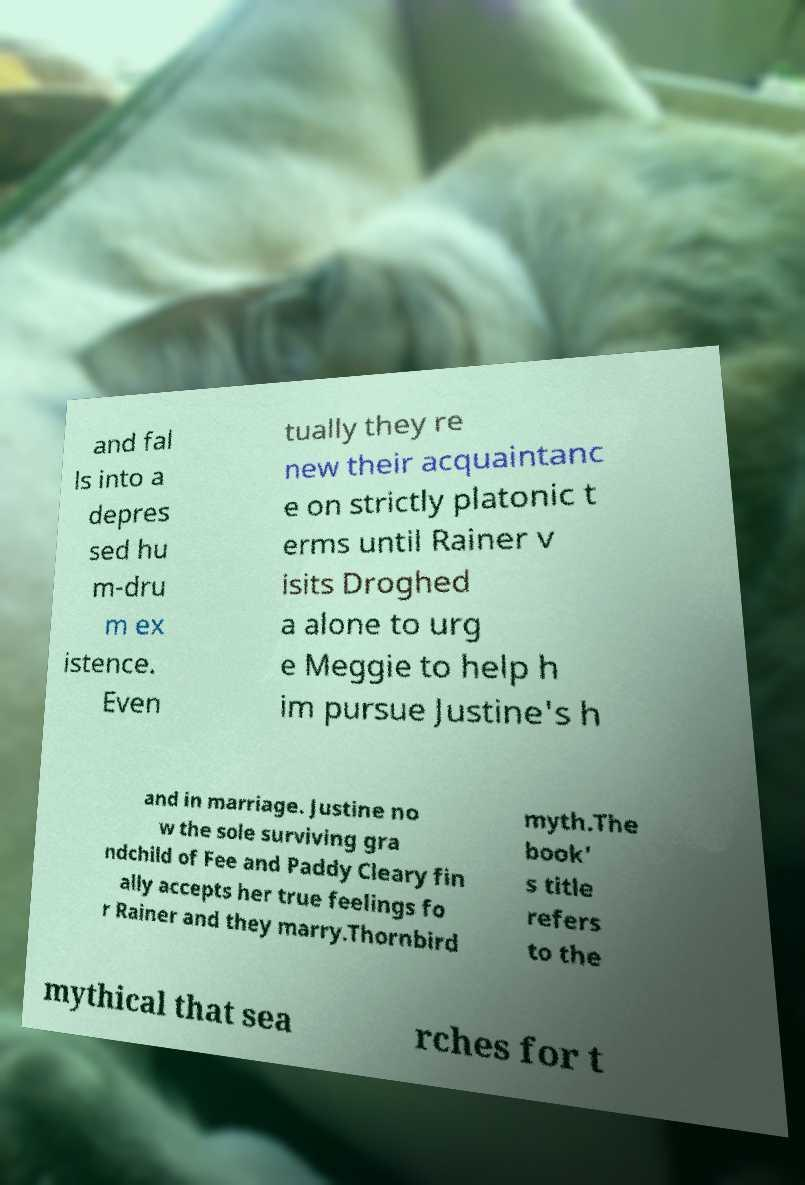Could you extract and type out the text from this image? and fal ls into a depres sed hu m-dru m ex istence. Even tually they re new their acquaintanc e on strictly platonic t erms until Rainer v isits Droghed a alone to urg e Meggie to help h im pursue Justine's h and in marriage. Justine no w the sole surviving gra ndchild of Fee and Paddy Cleary fin ally accepts her true feelings fo r Rainer and they marry.Thornbird myth.The book' s title refers to the mythical that sea rches for t 